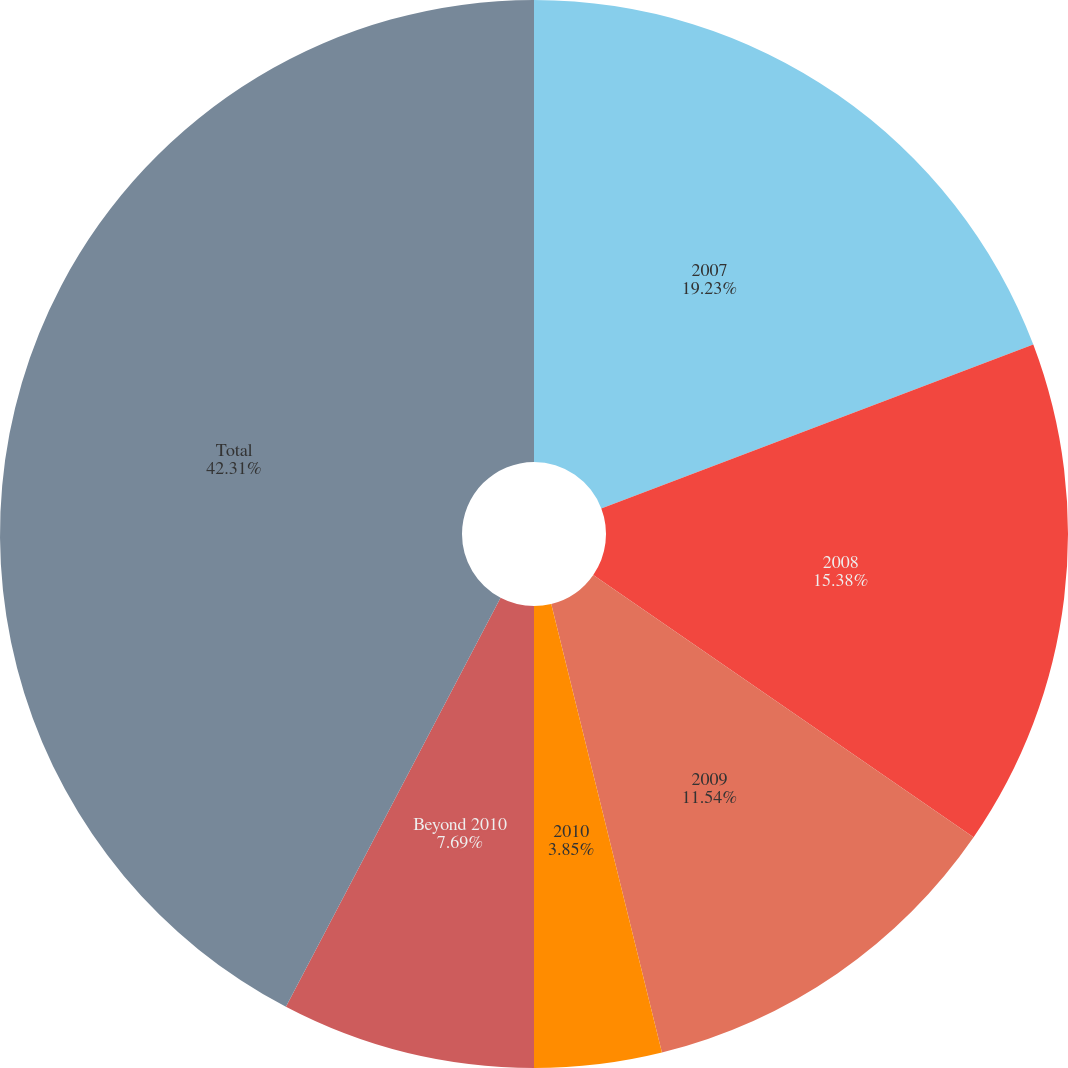Convert chart. <chart><loc_0><loc_0><loc_500><loc_500><pie_chart><fcel>2007<fcel>2008<fcel>2009<fcel>2010<fcel>Beyond 2010<fcel>Total<nl><fcel>19.23%<fcel>15.38%<fcel>11.54%<fcel>3.85%<fcel>7.69%<fcel>42.31%<nl></chart> 